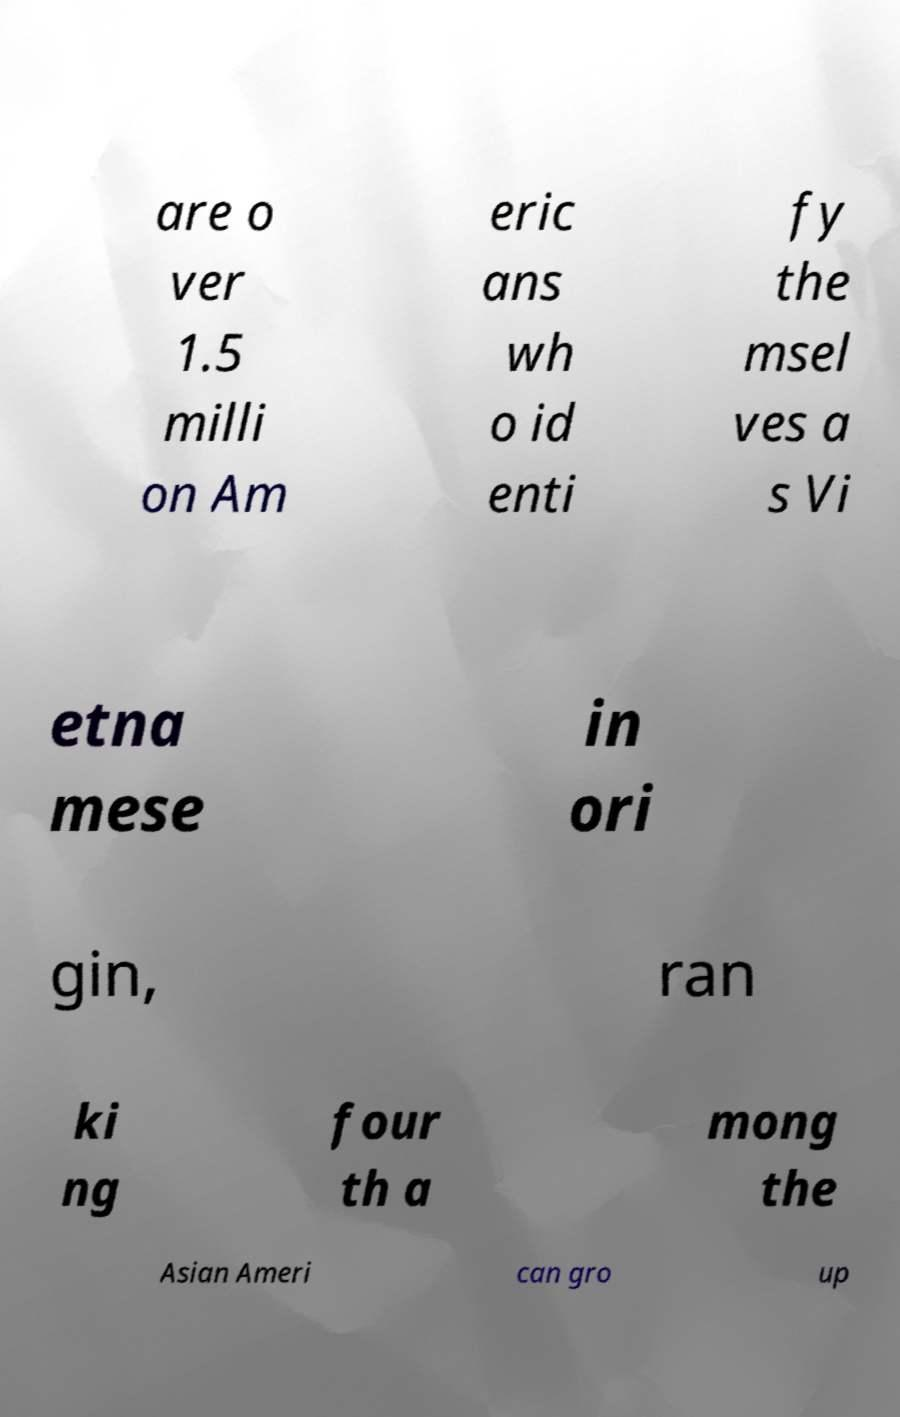Could you assist in decoding the text presented in this image and type it out clearly? are o ver 1.5 milli on Am eric ans wh o id enti fy the msel ves a s Vi etna mese in ori gin, ran ki ng four th a mong the Asian Ameri can gro up 